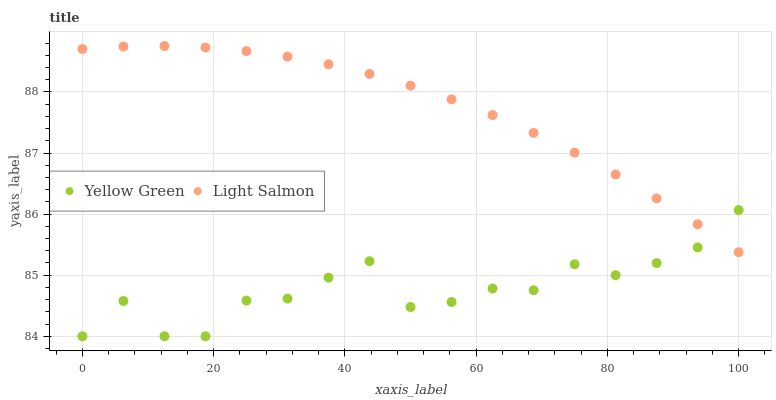Does Yellow Green have the minimum area under the curve?
Answer yes or no. Yes. Does Light Salmon have the maximum area under the curve?
Answer yes or no. Yes. Does Yellow Green have the maximum area under the curve?
Answer yes or no. No. Is Light Salmon the smoothest?
Answer yes or no. Yes. Is Yellow Green the roughest?
Answer yes or no. Yes. Is Yellow Green the smoothest?
Answer yes or no. No. Does Yellow Green have the lowest value?
Answer yes or no. Yes. Does Light Salmon have the highest value?
Answer yes or no. Yes. Does Yellow Green have the highest value?
Answer yes or no. No. Does Light Salmon intersect Yellow Green?
Answer yes or no. Yes. Is Light Salmon less than Yellow Green?
Answer yes or no. No. Is Light Salmon greater than Yellow Green?
Answer yes or no. No. 